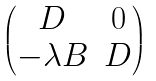<formula> <loc_0><loc_0><loc_500><loc_500>\begin{pmatrix} D & 0 \\ - \lambda B & D \end{pmatrix}</formula> 